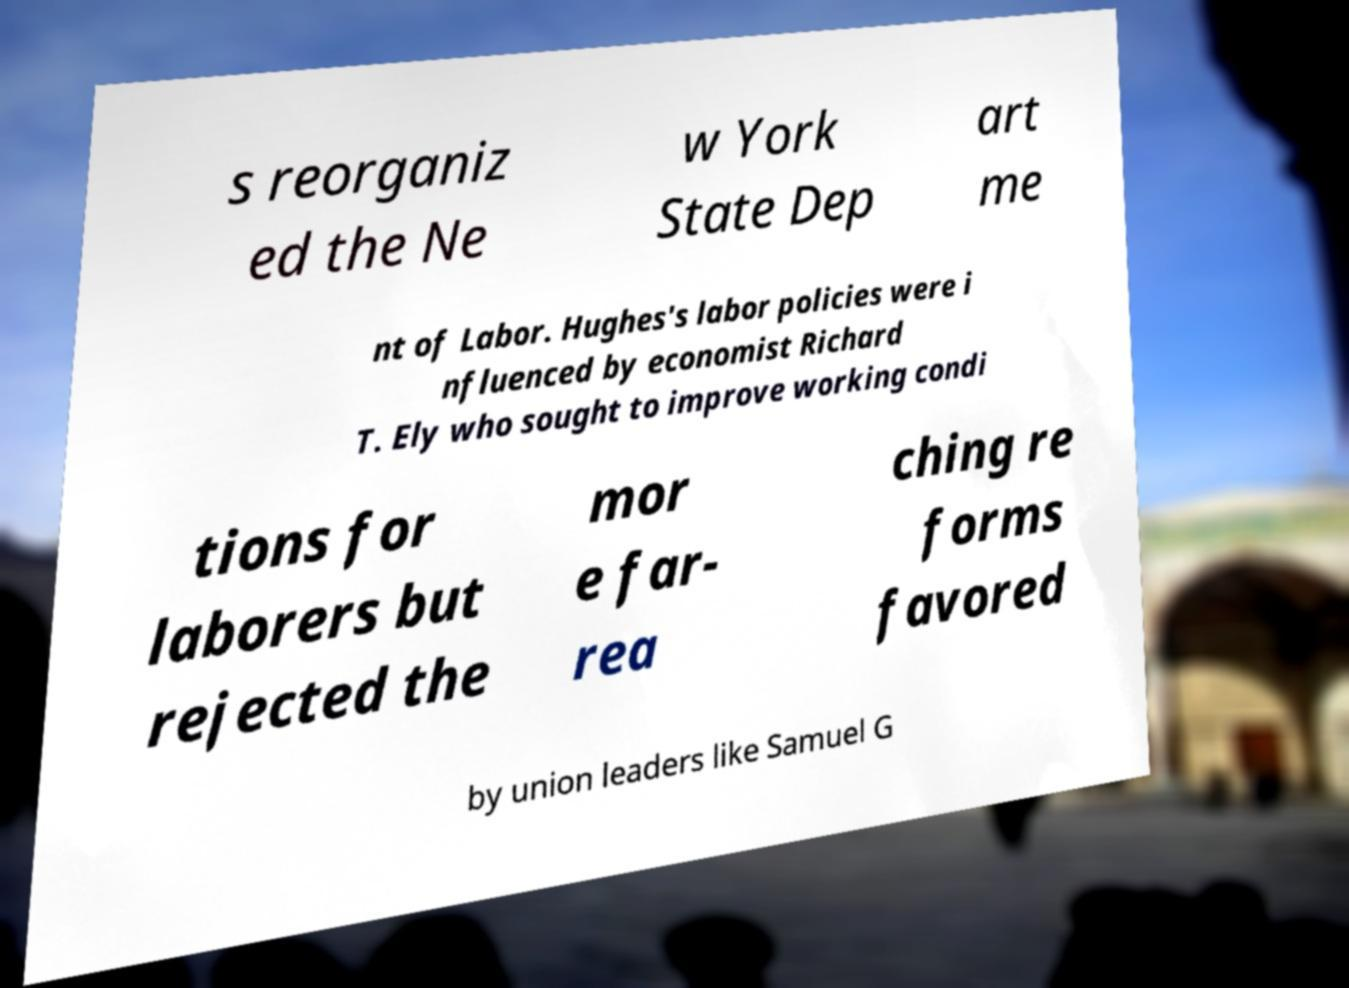What messages or text are displayed in this image? I need them in a readable, typed format. s reorganiz ed the Ne w York State Dep art me nt of Labor. Hughes's labor policies were i nfluenced by economist Richard T. Ely who sought to improve working condi tions for laborers but rejected the mor e far- rea ching re forms favored by union leaders like Samuel G 